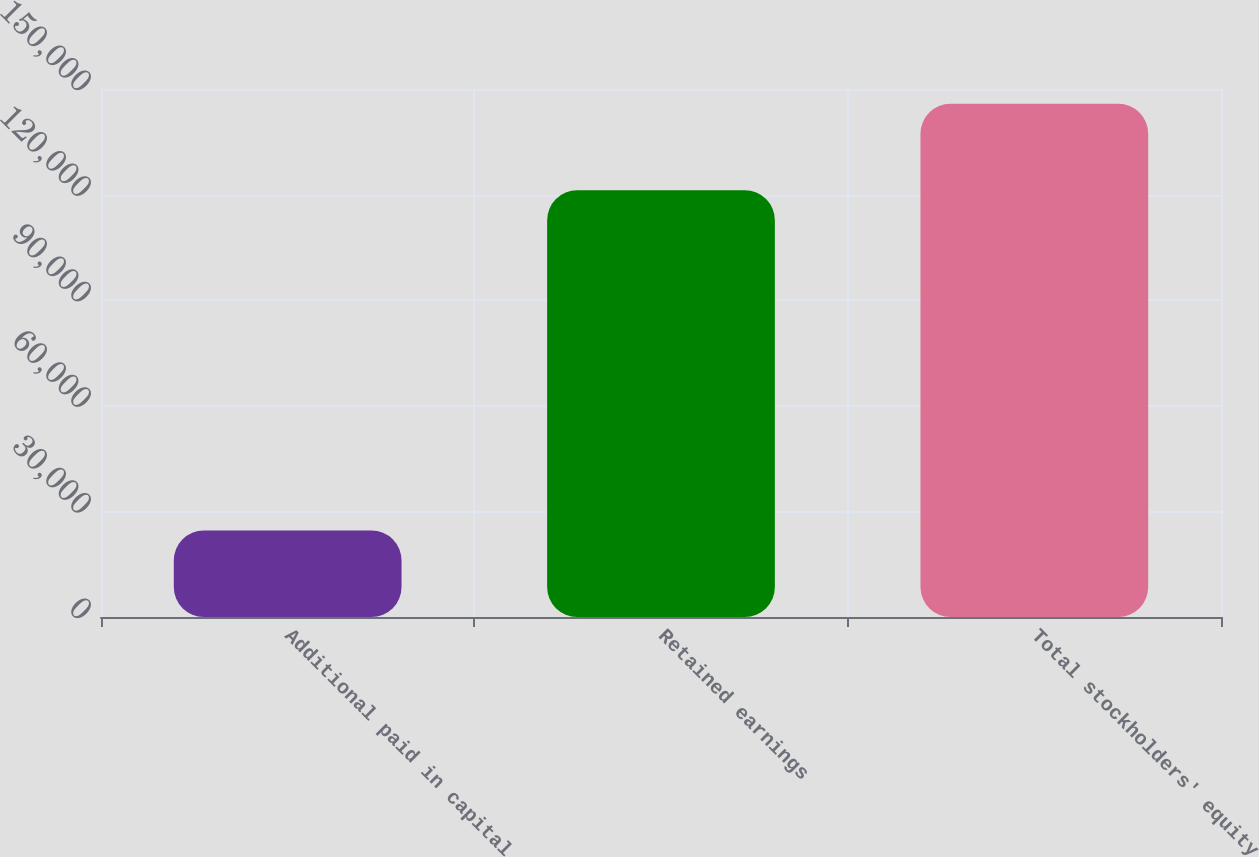Convert chart. <chart><loc_0><loc_0><loc_500><loc_500><bar_chart><fcel>Additional paid in capital<fcel>Retained earnings<fcel>Total stockholders' equity<nl><fcel>24575<fcel>121270<fcel>145845<nl></chart> 